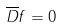Convert formula to latex. <formula><loc_0><loc_0><loc_500><loc_500>\overline { D } f = 0</formula> 